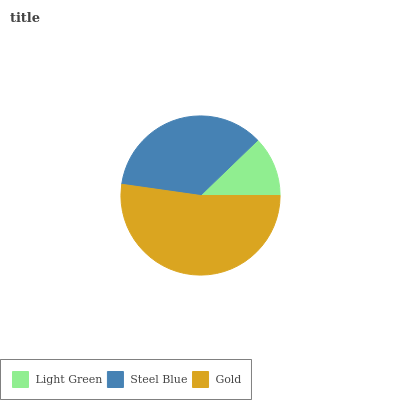Is Light Green the minimum?
Answer yes or no. Yes. Is Gold the maximum?
Answer yes or no. Yes. Is Steel Blue the minimum?
Answer yes or no. No. Is Steel Blue the maximum?
Answer yes or no. No. Is Steel Blue greater than Light Green?
Answer yes or no. Yes. Is Light Green less than Steel Blue?
Answer yes or no. Yes. Is Light Green greater than Steel Blue?
Answer yes or no. No. Is Steel Blue less than Light Green?
Answer yes or no. No. Is Steel Blue the high median?
Answer yes or no. Yes. Is Steel Blue the low median?
Answer yes or no. Yes. Is Gold the high median?
Answer yes or no. No. Is Gold the low median?
Answer yes or no. No. 